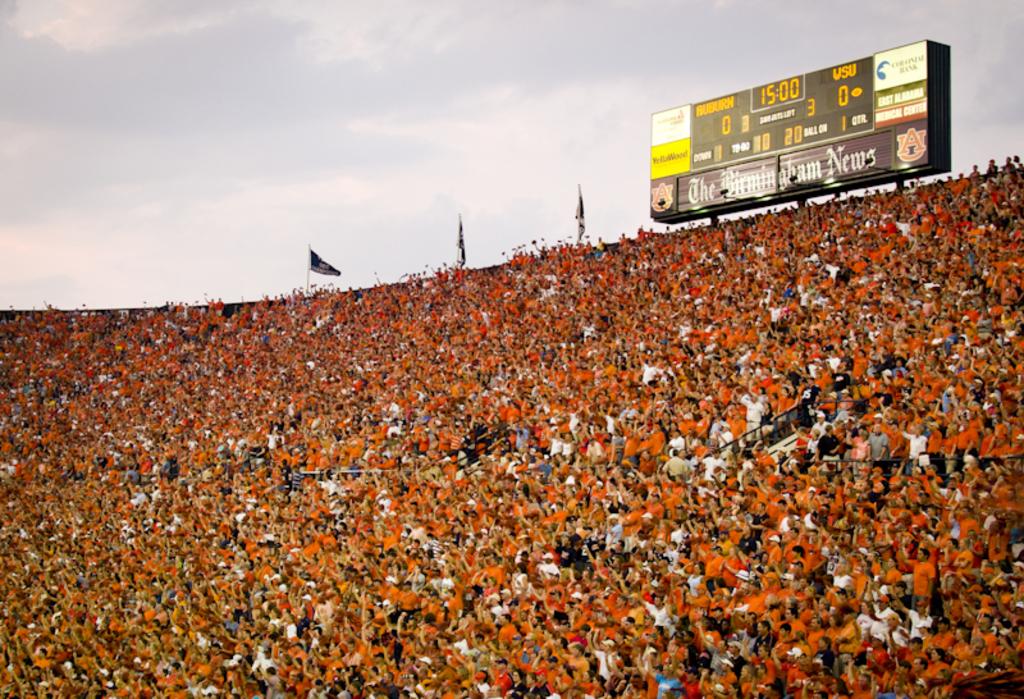What is the current game time?
Ensure brevity in your answer.  15:00. What is wsu's score?
Offer a very short reply. 0. 